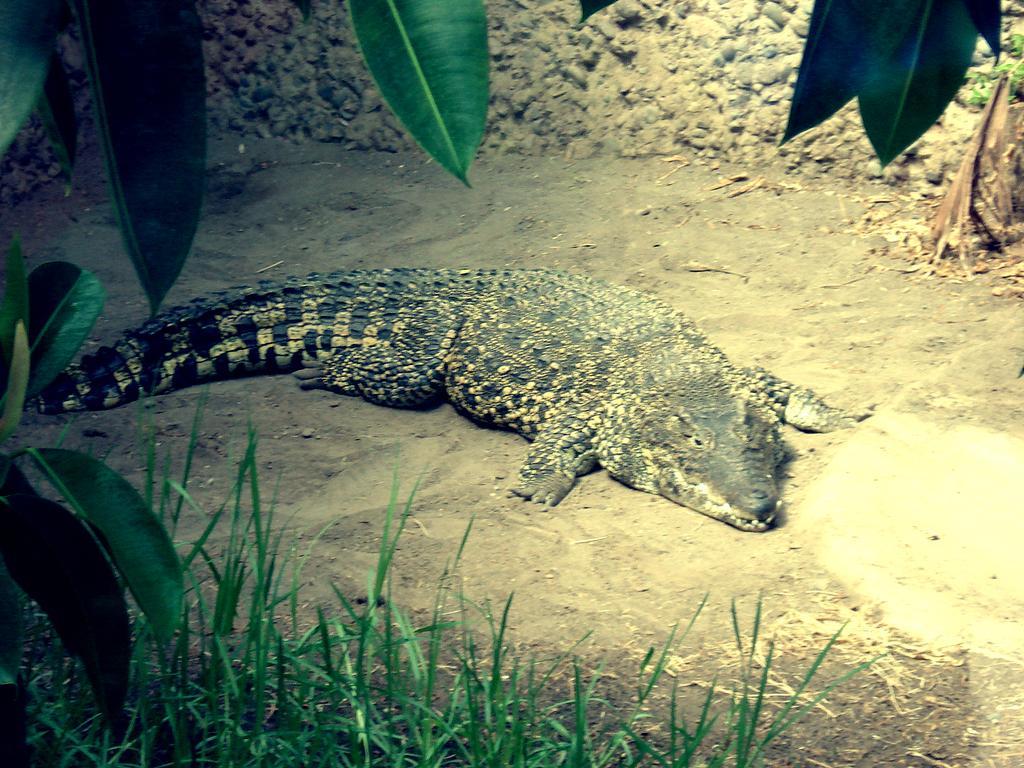How would you summarize this image in a sentence or two? In this picture we can see a crocodile on the ground, grass, leaves and in the background we can see the wall. 